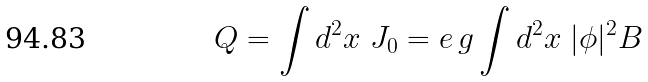<formula> <loc_0><loc_0><loc_500><loc_500>Q = \int d ^ { 2 } x \ J _ { 0 } = e \, g \int d ^ { 2 } x \ | \phi | ^ { 2 } B</formula> 